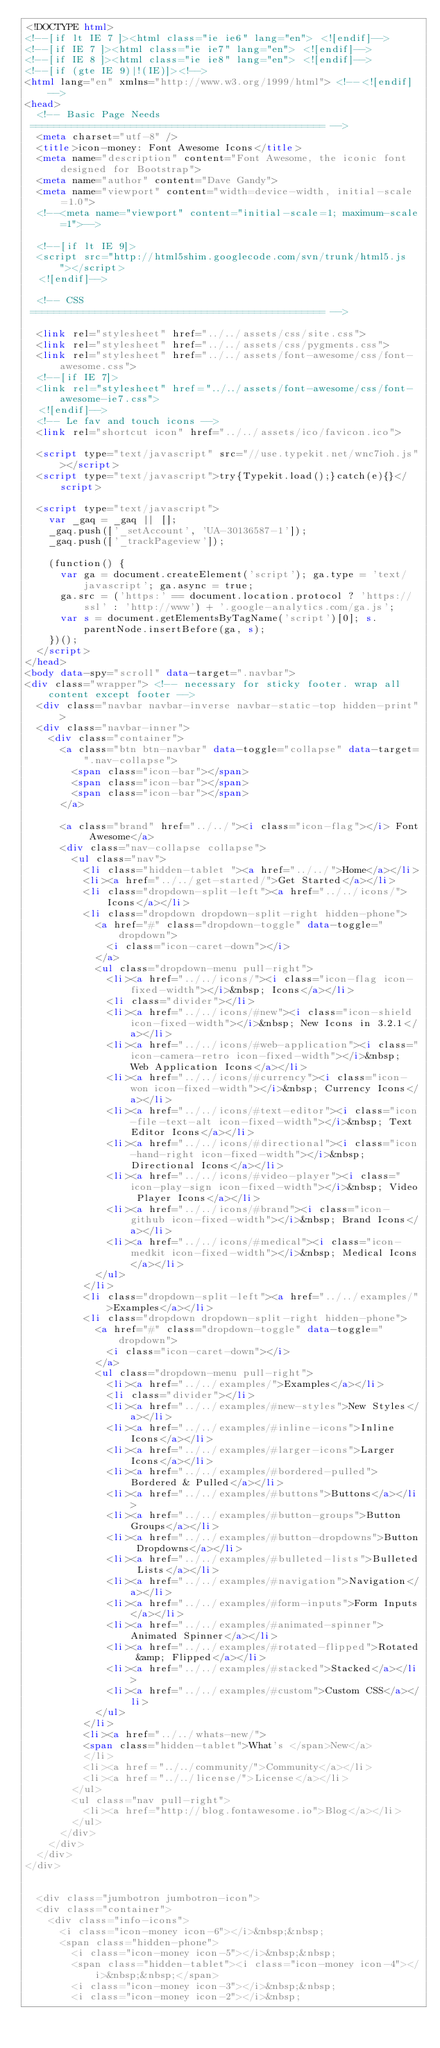Convert code to text. <code><loc_0><loc_0><loc_500><loc_500><_HTML_><!DOCTYPE html>
<!--[if lt IE 7 ]><html class="ie ie6" lang="en"> <![endif]-->
<!--[if IE 7 ]><html class="ie ie7" lang="en"> <![endif]-->
<!--[if IE 8 ]><html class="ie ie8" lang="en"> <![endif]-->
<!--[if (gte IE 9)|!(IE)]><!-->
<html lang="en" xmlns="http://www.w3.org/1999/html"> <!--<![endif]-->
<head>
  <!-- Basic Page Needs
 ================================================== -->
  <meta charset="utf-8" />
  <title>icon-money: Font Awesome Icons</title>
  <meta name="description" content="Font Awesome, the iconic font designed for Bootstrap">
  <meta name="author" content="Dave Gandy">
  <meta name="viewport" content="width=device-width, initial-scale=1.0">
  <!--<meta name="viewport" content="initial-scale=1; maximum-scale=1">-->

  <!--[if lt IE 9]>
  <script src="http://html5shim.googlecode.com/svn/trunk/html5.js"></script>
  <![endif]-->

  <!-- CSS
 ================================================== -->

  <link rel="stylesheet" href="../../assets/css/site.css">
  <link rel="stylesheet" href="../../assets/css/pygments.css">
  <link rel="stylesheet" href="../../assets/font-awesome/css/font-awesome.css">
  <!--[if IE 7]>
  <link rel="stylesheet" href="../../assets/font-awesome/css/font-awesome-ie7.css">
  <![endif]-->
  <!-- Le fav and touch icons -->
  <link rel="shortcut icon" href="../../assets/ico/favicon.ico">

  <script type="text/javascript" src="//use.typekit.net/wnc7ioh.js"></script>
  <script type="text/javascript">try{Typekit.load();}catch(e){}</script>

  <script type="text/javascript">
    var _gaq = _gaq || [];
    _gaq.push(['_setAccount', 'UA-30136587-1']);
    _gaq.push(['_trackPageview']);

    (function() {
      var ga = document.createElement('script'); ga.type = 'text/javascript'; ga.async = true;
      ga.src = ('https:' == document.location.protocol ? 'https://ssl' : 'http://www') + '.google-analytics.com/ga.js';
      var s = document.getElementsByTagName('script')[0]; s.parentNode.insertBefore(ga, s);
    })();
  </script>
</head>
<body data-spy="scroll" data-target=".navbar">
<div class="wrapper"> <!-- necessary for sticky footer. wrap all content except footer -->
  <div class="navbar navbar-inverse navbar-static-top hidden-print">
  <div class="navbar-inner">
    <div class="container">
      <a class="btn btn-navbar" data-toggle="collapse" data-target=".nav-collapse">
        <span class="icon-bar"></span>
        <span class="icon-bar"></span>
        <span class="icon-bar"></span>
      </a>

      <a class="brand" href="../../"><i class="icon-flag"></i> Font Awesome</a>
      <div class="nav-collapse collapse">
        <ul class="nav">
          <li class="hidden-tablet "><a href="../../">Home</a></li>
          <li><a href="../../get-started/">Get Started</a></li>
          <li class="dropdown-split-left"><a href="../../icons/">Icons</a></li>
          <li class="dropdown dropdown-split-right hidden-phone">
            <a href="#" class="dropdown-toggle" data-toggle="dropdown">
              <i class="icon-caret-down"></i>
            </a>
            <ul class="dropdown-menu pull-right">
              <li><a href="../../icons/"><i class="icon-flag icon-fixed-width"></i>&nbsp; Icons</a></li>
              <li class="divider"></li>
              <li><a href="../../icons/#new"><i class="icon-shield icon-fixed-width"></i>&nbsp; New Icons in 3.2.1</a></li>
              <li><a href="../../icons/#web-application"><i class="icon-camera-retro icon-fixed-width"></i>&nbsp; Web Application Icons</a></li>
              <li><a href="../../icons/#currency"><i class="icon-won icon-fixed-width"></i>&nbsp; Currency Icons</a></li>
              <li><a href="../../icons/#text-editor"><i class="icon-file-text-alt icon-fixed-width"></i>&nbsp; Text Editor Icons</a></li>
              <li><a href="../../icons/#directional"><i class="icon-hand-right icon-fixed-width"></i>&nbsp; Directional Icons</a></li>
              <li><a href="../../icons/#video-player"><i class="icon-play-sign icon-fixed-width"></i>&nbsp; Video Player Icons</a></li>
              <li><a href="../../icons/#brand"><i class="icon-github icon-fixed-width"></i>&nbsp; Brand Icons</a></li>
              <li><a href="../../icons/#medical"><i class="icon-medkit icon-fixed-width"></i>&nbsp; Medical Icons</a></li>
            </ul>
          </li>
          <li class="dropdown-split-left"><a href="../../examples/">Examples</a></li>
          <li class="dropdown dropdown-split-right hidden-phone">
            <a href="#" class="dropdown-toggle" data-toggle="dropdown">
              <i class="icon-caret-down"></i>
            </a>
            <ul class="dropdown-menu pull-right">
              <li><a href="../../examples/">Examples</a></li>
              <li class="divider"></li>
              <li><a href="../../examples/#new-styles">New Styles</a></li>
              <li><a href="../../examples/#inline-icons">Inline Icons</a></li>
              <li><a href="../../examples/#larger-icons">Larger Icons</a></li>
              <li><a href="../../examples/#bordered-pulled">Bordered & Pulled</a></li>
              <li><a href="../../examples/#buttons">Buttons</a></li>
              <li><a href="../../examples/#button-groups">Button Groups</a></li>
              <li><a href="../../examples/#button-dropdowns">Button Dropdowns</a></li>
              <li><a href="../../examples/#bulleted-lists">Bulleted Lists</a></li>
              <li><a href="../../examples/#navigation">Navigation</a></li>
              <li><a href="../../examples/#form-inputs">Form Inputs</a></li>
              <li><a href="../../examples/#animated-spinner">Animated Spinner</a></li>
              <li><a href="../../examples/#rotated-flipped">Rotated &amp; Flipped</a></li>
              <li><a href="../../examples/#stacked">Stacked</a></li>
              <li><a href="../../examples/#custom">Custom CSS</a></li>
            </ul>
          </li>
          <li><a href="../../whats-new/">
          <span class="hidden-tablet">What's </span>New</a>
          </li>
          <li><a href="../../community/">Community</a></li>
          <li><a href="../../license/">License</a></li>
        </ul>
        <ul class="nav pull-right">
          <li><a href="http://blog.fontawesome.io">Blog</a></li>
        </ul>
      </div>
    </div>
  </div>
</div>


  <div class="jumbotron jumbotron-icon">
  <div class="container">
    <div class="info-icons">
      <i class="icon-money icon-6"></i>&nbsp;&nbsp;
      <span class="hidden-phone">
        <i class="icon-money icon-5"></i>&nbsp;&nbsp;
        <span class="hidden-tablet"><i class="icon-money icon-4"></i>&nbsp;&nbsp;</span>
        <i class="icon-money icon-3"></i>&nbsp;&nbsp;
        <i class="icon-money icon-2"></i>&nbsp;</code> 